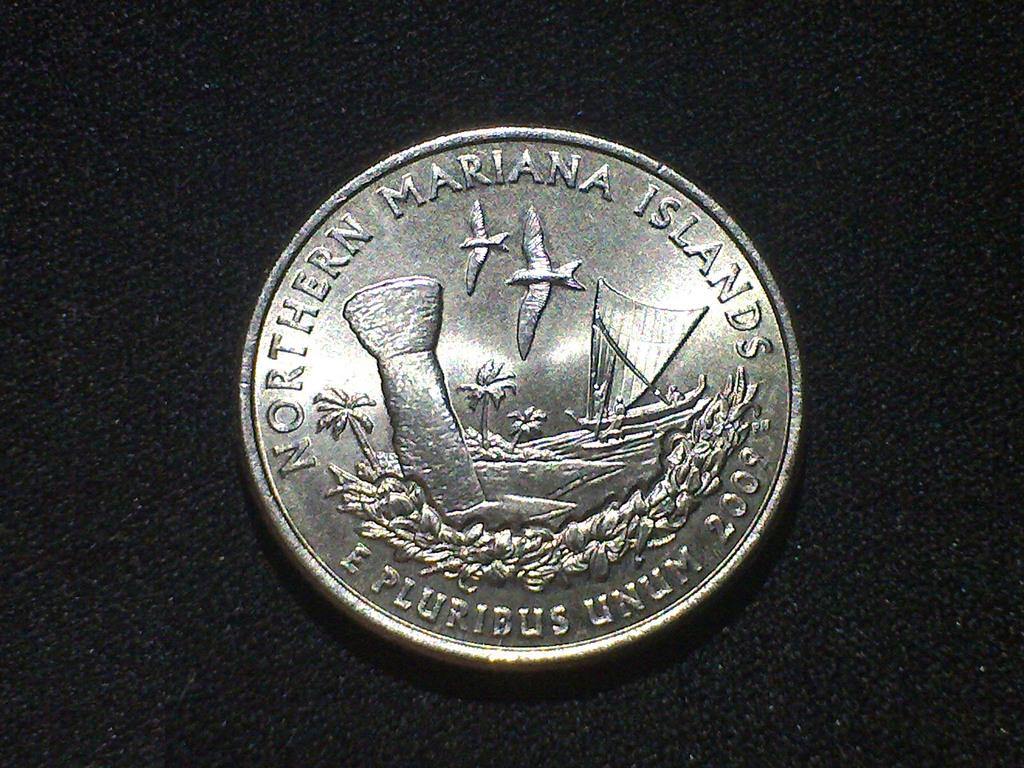What object is present on the black surface in the picture? There is a coin on the black surface in the picture. What is depicted on the coin? There is text and a ship depicted on the coin. How many birds are depicted on the coin? There are two birds depicted on the coin. What type of yarn is being used to create the ship on the coin? There is no yarn present in the image; the ship is depicted on the coin itself. 